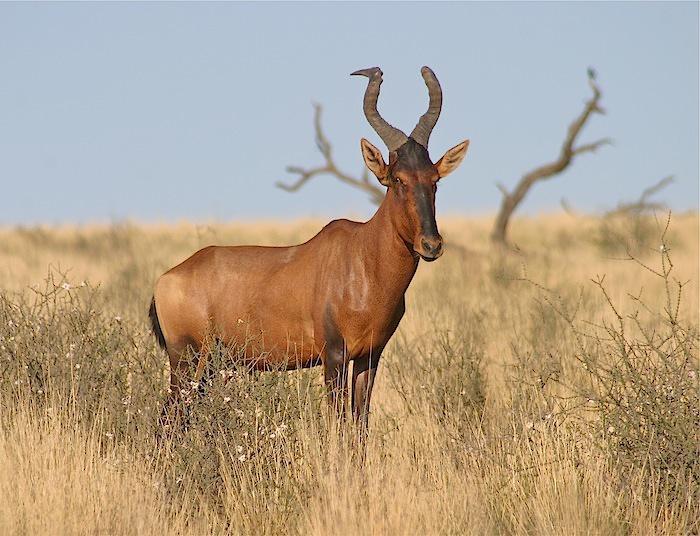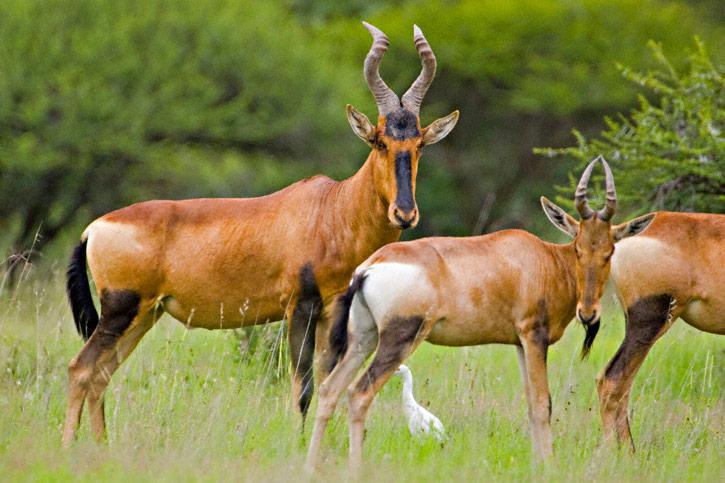The first image is the image on the left, the second image is the image on the right. Examine the images to the left and right. Is the description "There are two buffalo in total." accurate? Answer yes or no. No. The first image is the image on the left, the second image is the image on the right. For the images shown, is this caption "One of the animals has a red circle on it." true? Answer yes or no. No. 